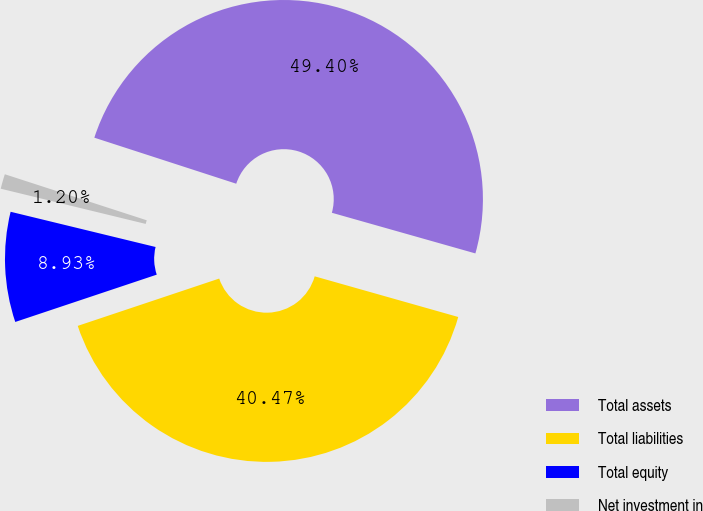<chart> <loc_0><loc_0><loc_500><loc_500><pie_chart><fcel>Total assets<fcel>Total liabilities<fcel>Total equity<fcel>Net investment in<nl><fcel>49.4%<fcel>40.47%<fcel>8.93%<fcel>1.2%<nl></chart> 